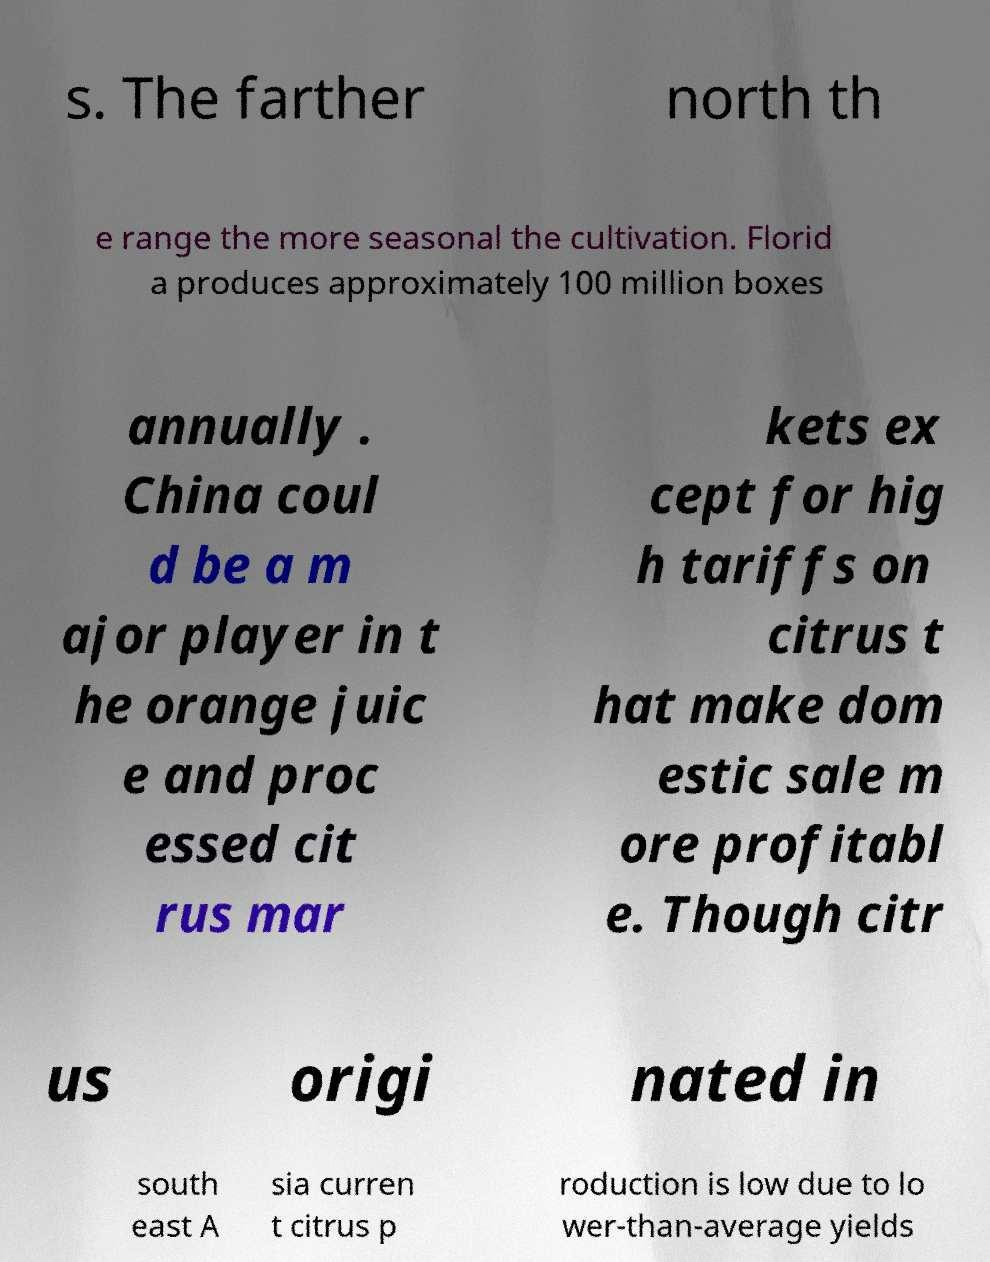What messages or text are displayed in this image? I need them in a readable, typed format. s. The farther north th e range the more seasonal the cultivation. Florid a produces approximately 100 million boxes annually . China coul d be a m ajor player in t he orange juic e and proc essed cit rus mar kets ex cept for hig h tariffs on citrus t hat make dom estic sale m ore profitabl e. Though citr us origi nated in south east A sia curren t citrus p roduction is low due to lo wer-than-average yields 